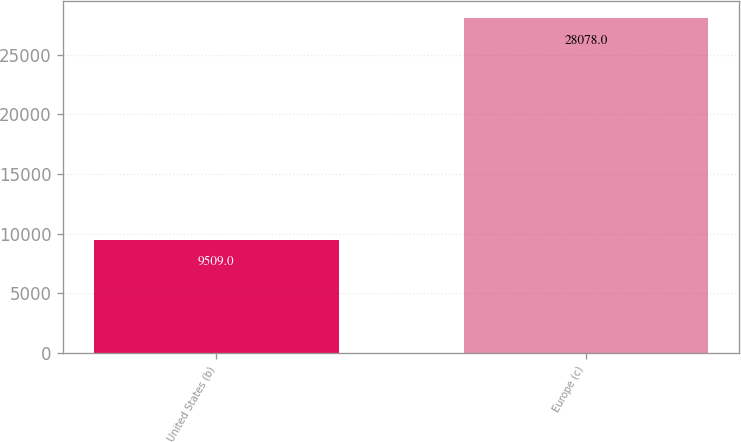Convert chart to OTSL. <chart><loc_0><loc_0><loc_500><loc_500><bar_chart><fcel>United States (b)<fcel>Europe (c)<nl><fcel>9509<fcel>28078<nl></chart> 